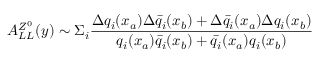<formula> <loc_0><loc_0><loc_500><loc_500>A _ { L L } ^ { Z ^ { 0 } } ( y ) \sim \Sigma _ { i } { \frac { \Delta q _ { i } ( x _ { a } ) \Delta \bar { q } _ { i } ( x _ { b } ) + \Delta \bar { q } _ { i } ( x _ { a } ) \Delta q _ { i } ( x _ { b } ) } { q _ { i } ( x _ { a } ) \bar { q } _ { i } ( x _ { b } ) + \bar { q } _ { i } ( x _ { a } ) q _ { i } ( x _ { b } ) } }</formula> 